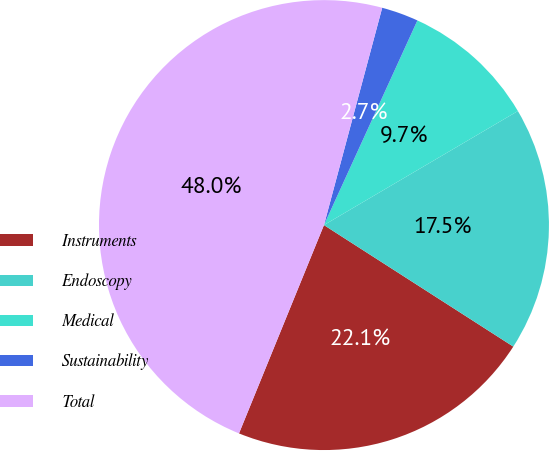Convert chart. <chart><loc_0><loc_0><loc_500><loc_500><pie_chart><fcel>Instruments<fcel>Endoscopy<fcel>Medical<fcel>Sustainability<fcel>Total<nl><fcel>22.08%<fcel>17.54%<fcel>9.72%<fcel>2.65%<fcel>48.0%<nl></chart> 